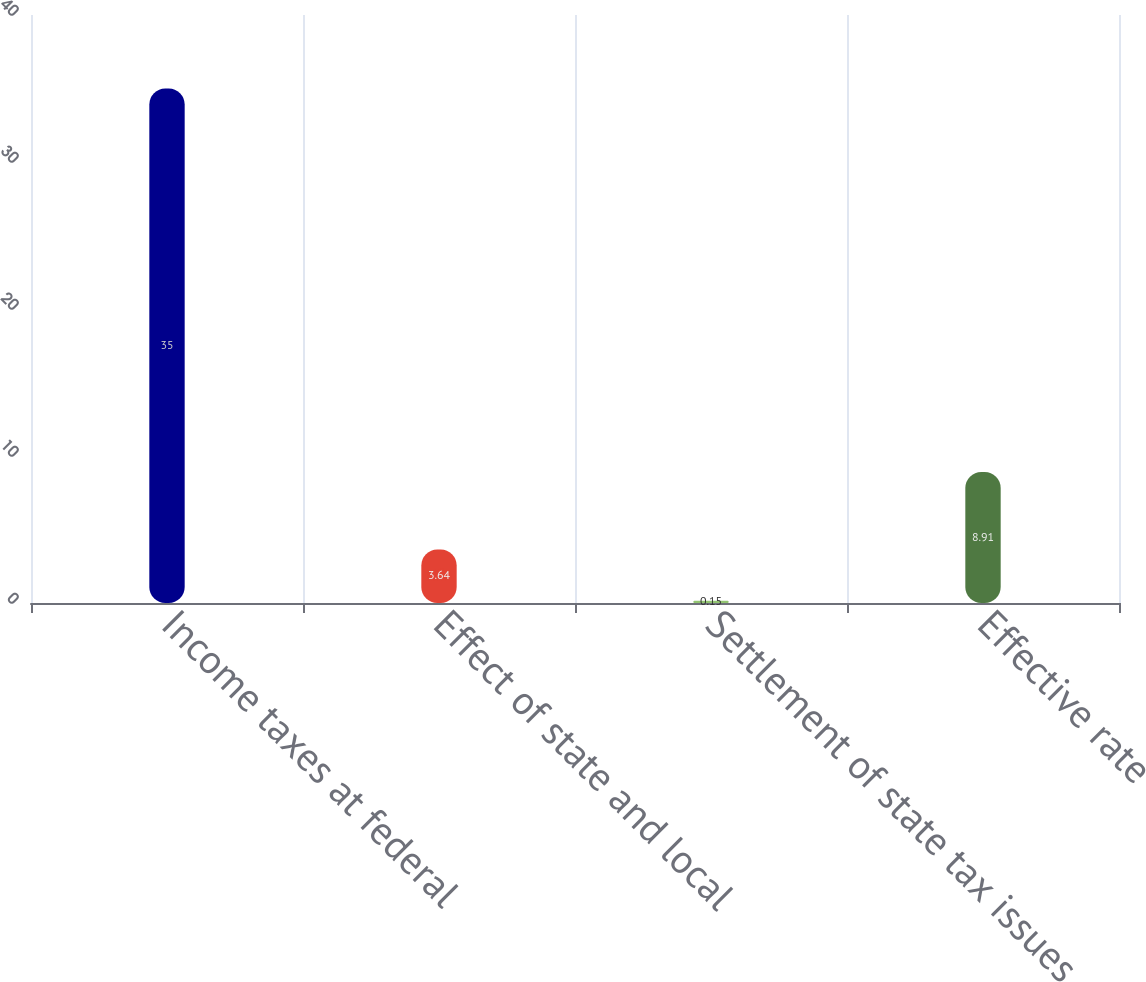Convert chart to OTSL. <chart><loc_0><loc_0><loc_500><loc_500><bar_chart><fcel>Income taxes at federal<fcel>Effect of state and local<fcel>Settlement of state tax issues<fcel>Effective rate<nl><fcel>35<fcel>3.64<fcel>0.15<fcel>8.91<nl></chart> 